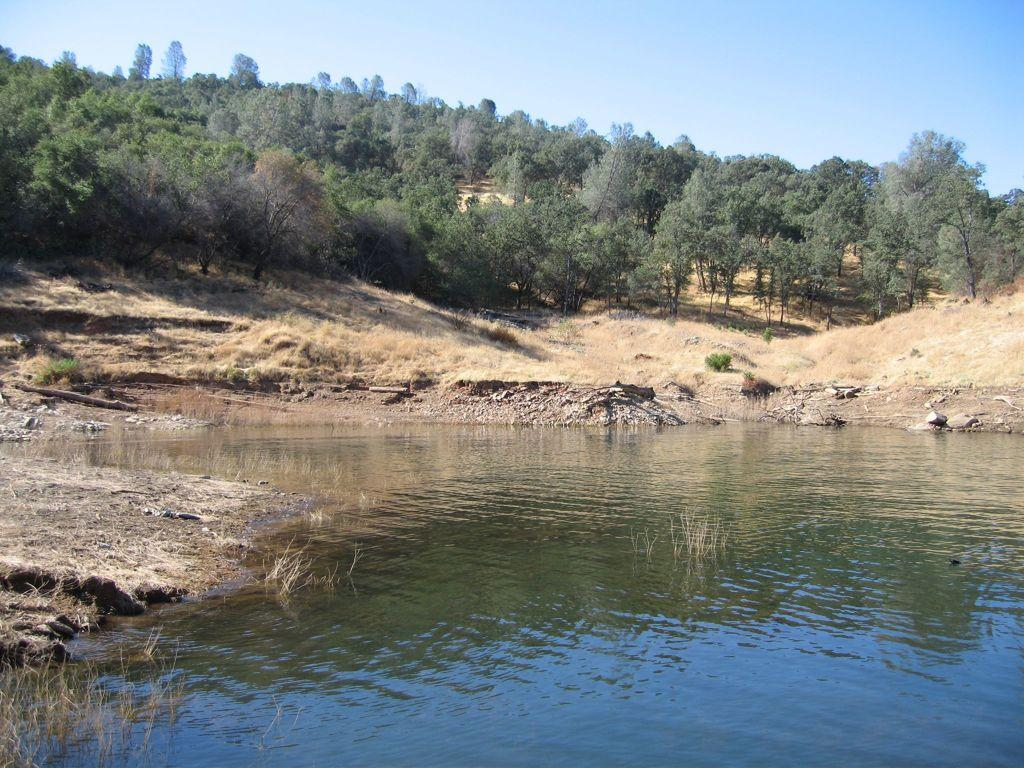What is the primary element visible in the image? There is water in the image. What can be seen in the distance behind the water? There are trees in the background of the image. What else is visible in the background of the image? The sky is visible in the background of the image. What type of material is present on the sides of the water? There are stones on the sides of the water. How many goats are standing on the stones in the image? There are no goats present in the image. What type of crook is being used by the lizards in the image? There are no lizards or crooks present in the image. 